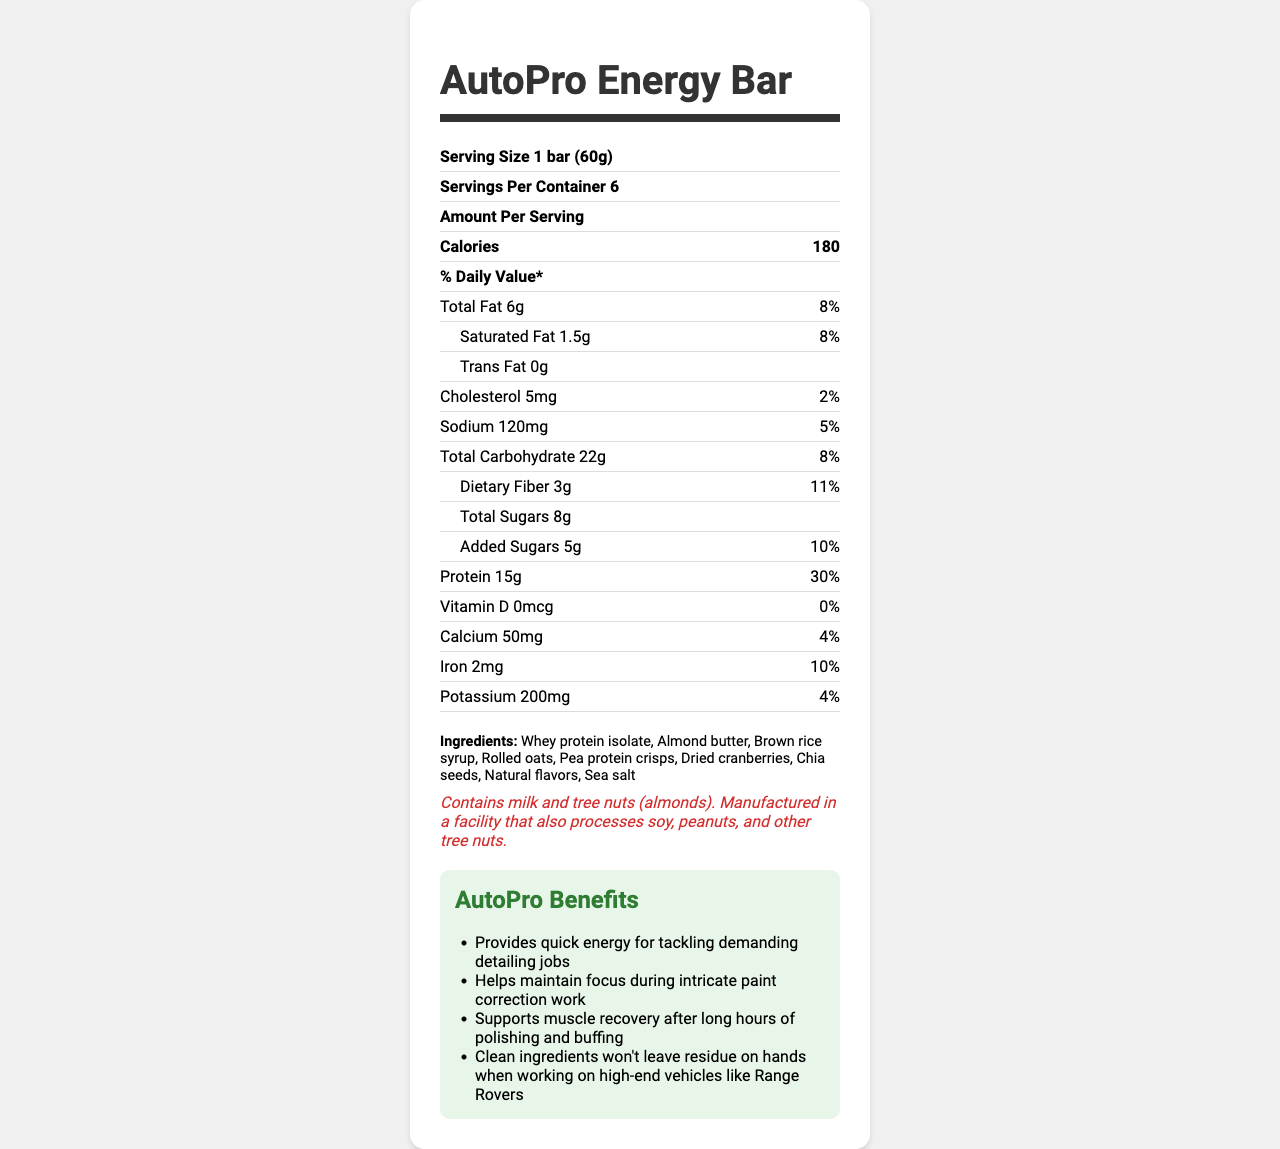what is the serving size of the AutoPro Energy Bar? The serving size is explicitly listed as "1 bar (60g)" under the "Nutrition Facts" section.
Answer: 1 bar (60g) how many servings are there per container? The document states under "Servings Per Container" that there are 6 servings per container.
Answer: 6 how many calories are there in one serving? The document lists "Calories" as 180 per serving.
Answer: 180 what is the total fat content per serving? The document states "Total Fat" content is 6g per serving.
Answer: 6g how much protein is in one bar? The document indicates "Protein" content as 15g per serving.
Answer: 15g how many grams of added sugars are there? The "Added Sugars" section lists 5g per serving.
Answer: 5g What is the daily value percentage of saturated fat in one serving? A. 5% B. 8% C. 12% D. 15% The "Saturated Fat" section indicates that there is "1.5g" of saturated fat, which is listed as "8%" of the daily value.
Answer: B. 8% which ingredient is listed first on the ingredients list? A. Brown rice syrup B. Almond butter C. Whey protein isolate The first ingredient listed is "Whey protein isolate."
Answer: C. Whey protein isolate Does the AutoPro Energy Bar contain any trans fat? Under "Trans Fat," the document explicitly states "0g."
Answer: No Describe the main benefits of the AutoPro Energy Bar for automotive professionals. The document outlines the main benefits as providing quick energy for demanding jobs, maintaining focus, supporting muscle recovery, and having clean ingredients that won't leave residue.
Answer: Provides quick energy, helps maintain focus, supports muscle recovery, clean ingredients What is the exact amount of sodium in one serving? The document lists "Sodium" content as 120mg per serving.
Answer: 120mg Can this energy bar be safely eaten by someone with a peanut allergy? The document states it is manufactured in a facility that processes peanuts, which implies potential cross-contamination, but it does not explicitly say it is safe.
Answer: Not enough information How many grams of dietary fiber are there in a single bar? The "Dietary Fiber" content is listed as 3g per serving.
Answer: 3g What marketing claim is associated with high protein content? A. Convenient on-the-go snack B. Supports muscle recovery C. High in protein for sustained energy D. No artificial preservatives The document claims "High in protein for sustained energy during long detailing sessions."
Answer: C. High in protein for sustained energy What percentage of daily calcium is provided by one serving of the energy bar? The "Calcium" section lists the daily value percentage as "4%."
Answer: 4% Does the product contain Vitamin D? The "Vitamin D" section shows "0mcg" and "0%" daily value, indicating the product does not contain Vitamin D.
Answer: No What is the total carbohydrate content per serving of the energy bar? The "Total Carbohydrate" section lists 22g per serving.
Answer: 22g List two ingredients included in the AutoPro Energy Bar. The ingredients list includes "Whey protein isolate" and "Almond butter," among others.
Answer: Whey protein isolate, Almond butter How much potassium does one serving contain? The "Potassium" content is listed as 200mg per serving.
Answer: 200mg 